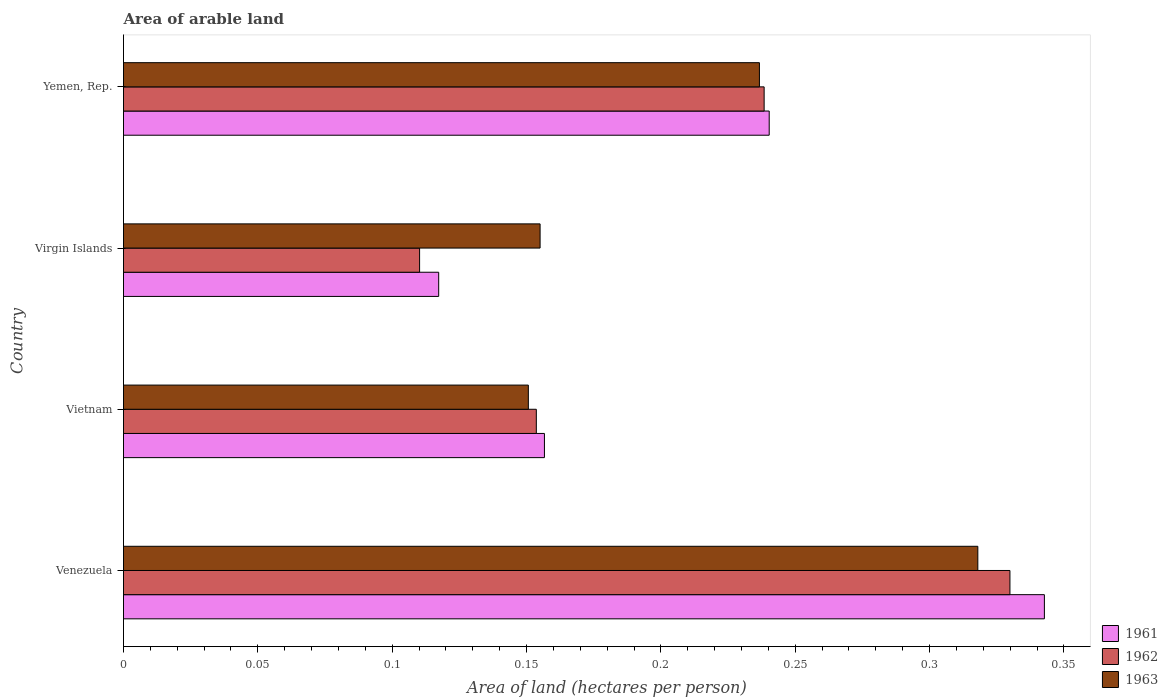How many groups of bars are there?
Offer a terse response. 4. Are the number of bars per tick equal to the number of legend labels?
Provide a short and direct response. Yes. How many bars are there on the 3rd tick from the bottom?
Your answer should be compact. 3. What is the label of the 1st group of bars from the top?
Provide a short and direct response. Yemen, Rep. In how many cases, is the number of bars for a given country not equal to the number of legend labels?
Keep it short and to the point. 0. What is the total arable land in 1963 in Venezuela?
Provide a succinct answer. 0.32. Across all countries, what is the maximum total arable land in 1961?
Your answer should be compact. 0.34. Across all countries, what is the minimum total arable land in 1961?
Provide a short and direct response. 0.12. In which country was the total arable land in 1962 maximum?
Provide a succinct answer. Venezuela. In which country was the total arable land in 1962 minimum?
Provide a short and direct response. Virgin Islands. What is the total total arable land in 1963 in the graph?
Keep it short and to the point. 0.86. What is the difference between the total arable land in 1962 in Vietnam and that in Yemen, Rep.?
Ensure brevity in your answer.  -0.08. What is the difference between the total arable land in 1963 in Virgin Islands and the total arable land in 1962 in Yemen, Rep.?
Make the answer very short. -0.08. What is the average total arable land in 1962 per country?
Ensure brevity in your answer.  0.21. What is the difference between the total arable land in 1963 and total arable land in 1962 in Virgin Islands?
Offer a very short reply. 0.04. What is the ratio of the total arable land in 1963 in Vietnam to that in Yemen, Rep.?
Your answer should be very brief. 0.64. Is the difference between the total arable land in 1963 in Venezuela and Vietnam greater than the difference between the total arable land in 1962 in Venezuela and Vietnam?
Offer a very short reply. No. What is the difference between the highest and the second highest total arable land in 1962?
Your response must be concise. 0.09. What is the difference between the highest and the lowest total arable land in 1962?
Your response must be concise. 0.22. In how many countries, is the total arable land in 1962 greater than the average total arable land in 1962 taken over all countries?
Your response must be concise. 2. Is it the case that in every country, the sum of the total arable land in 1961 and total arable land in 1963 is greater than the total arable land in 1962?
Provide a succinct answer. Yes. How many countries are there in the graph?
Your answer should be very brief. 4. Are the values on the major ticks of X-axis written in scientific E-notation?
Make the answer very short. No. Does the graph contain grids?
Your answer should be compact. No. How many legend labels are there?
Provide a succinct answer. 3. How are the legend labels stacked?
Provide a succinct answer. Vertical. What is the title of the graph?
Keep it short and to the point. Area of arable land. Does "1985" appear as one of the legend labels in the graph?
Provide a short and direct response. No. What is the label or title of the X-axis?
Provide a short and direct response. Area of land (hectares per person). What is the Area of land (hectares per person) of 1961 in Venezuela?
Provide a short and direct response. 0.34. What is the Area of land (hectares per person) in 1962 in Venezuela?
Ensure brevity in your answer.  0.33. What is the Area of land (hectares per person) in 1963 in Venezuela?
Keep it short and to the point. 0.32. What is the Area of land (hectares per person) in 1961 in Vietnam?
Offer a terse response. 0.16. What is the Area of land (hectares per person) of 1962 in Vietnam?
Provide a succinct answer. 0.15. What is the Area of land (hectares per person) in 1963 in Vietnam?
Provide a succinct answer. 0.15. What is the Area of land (hectares per person) in 1961 in Virgin Islands?
Offer a very short reply. 0.12. What is the Area of land (hectares per person) of 1962 in Virgin Islands?
Your answer should be very brief. 0.11. What is the Area of land (hectares per person) in 1963 in Virgin Islands?
Your answer should be very brief. 0.16. What is the Area of land (hectares per person) of 1961 in Yemen, Rep.?
Offer a very short reply. 0.24. What is the Area of land (hectares per person) in 1962 in Yemen, Rep.?
Ensure brevity in your answer.  0.24. What is the Area of land (hectares per person) of 1963 in Yemen, Rep.?
Keep it short and to the point. 0.24. Across all countries, what is the maximum Area of land (hectares per person) of 1961?
Your answer should be compact. 0.34. Across all countries, what is the maximum Area of land (hectares per person) in 1962?
Ensure brevity in your answer.  0.33. Across all countries, what is the maximum Area of land (hectares per person) in 1963?
Ensure brevity in your answer.  0.32. Across all countries, what is the minimum Area of land (hectares per person) of 1961?
Keep it short and to the point. 0.12. Across all countries, what is the minimum Area of land (hectares per person) in 1962?
Your response must be concise. 0.11. Across all countries, what is the minimum Area of land (hectares per person) of 1963?
Ensure brevity in your answer.  0.15. What is the total Area of land (hectares per person) in 1961 in the graph?
Ensure brevity in your answer.  0.86. What is the total Area of land (hectares per person) in 1962 in the graph?
Offer a very short reply. 0.83. What is the total Area of land (hectares per person) in 1963 in the graph?
Your answer should be compact. 0.86. What is the difference between the Area of land (hectares per person) of 1961 in Venezuela and that in Vietnam?
Provide a short and direct response. 0.19. What is the difference between the Area of land (hectares per person) of 1962 in Venezuela and that in Vietnam?
Provide a succinct answer. 0.18. What is the difference between the Area of land (hectares per person) in 1963 in Venezuela and that in Vietnam?
Offer a terse response. 0.17. What is the difference between the Area of land (hectares per person) in 1961 in Venezuela and that in Virgin Islands?
Provide a short and direct response. 0.23. What is the difference between the Area of land (hectares per person) of 1962 in Venezuela and that in Virgin Islands?
Your answer should be compact. 0.22. What is the difference between the Area of land (hectares per person) of 1963 in Venezuela and that in Virgin Islands?
Give a very brief answer. 0.16. What is the difference between the Area of land (hectares per person) in 1961 in Venezuela and that in Yemen, Rep.?
Offer a terse response. 0.1. What is the difference between the Area of land (hectares per person) of 1962 in Venezuela and that in Yemen, Rep.?
Ensure brevity in your answer.  0.09. What is the difference between the Area of land (hectares per person) in 1963 in Venezuela and that in Yemen, Rep.?
Your answer should be very brief. 0.08. What is the difference between the Area of land (hectares per person) of 1961 in Vietnam and that in Virgin Islands?
Keep it short and to the point. 0.04. What is the difference between the Area of land (hectares per person) of 1962 in Vietnam and that in Virgin Islands?
Keep it short and to the point. 0.04. What is the difference between the Area of land (hectares per person) of 1963 in Vietnam and that in Virgin Islands?
Provide a short and direct response. -0. What is the difference between the Area of land (hectares per person) in 1961 in Vietnam and that in Yemen, Rep.?
Give a very brief answer. -0.08. What is the difference between the Area of land (hectares per person) of 1962 in Vietnam and that in Yemen, Rep.?
Make the answer very short. -0.08. What is the difference between the Area of land (hectares per person) of 1963 in Vietnam and that in Yemen, Rep.?
Your answer should be very brief. -0.09. What is the difference between the Area of land (hectares per person) in 1961 in Virgin Islands and that in Yemen, Rep.?
Your answer should be compact. -0.12. What is the difference between the Area of land (hectares per person) in 1962 in Virgin Islands and that in Yemen, Rep.?
Provide a short and direct response. -0.13. What is the difference between the Area of land (hectares per person) in 1963 in Virgin Islands and that in Yemen, Rep.?
Make the answer very short. -0.08. What is the difference between the Area of land (hectares per person) in 1961 in Venezuela and the Area of land (hectares per person) in 1962 in Vietnam?
Ensure brevity in your answer.  0.19. What is the difference between the Area of land (hectares per person) in 1961 in Venezuela and the Area of land (hectares per person) in 1963 in Vietnam?
Your answer should be very brief. 0.19. What is the difference between the Area of land (hectares per person) in 1962 in Venezuela and the Area of land (hectares per person) in 1963 in Vietnam?
Keep it short and to the point. 0.18. What is the difference between the Area of land (hectares per person) of 1961 in Venezuela and the Area of land (hectares per person) of 1962 in Virgin Islands?
Your answer should be compact. 0.23. What is the difference between the Area of land (hectares per person) in 1961 in Venezuela and the Area of land (hectares per person) in 1963 in Virgin Islands?
Ensure brevity in your answer.  0.19. What is the difference between the Area of land (hectares per person) in 1962 in Venezuela and the Area of land (hectares per person) in 1963 in Virgin Islands?
Your answer should be compact. 0.17. What is the difference between the Area of land (hectares per person) of 1961 in Venezuela and the Area of land (hectares per person) of 1962 in Yemen, Rep.?
Your answer should be very brief. 0.1. What is the difference between the Area of land (hectares per person) in 1961 in Venezuela and the Area of land (hectares per person) in 1963 in Yemen, Rep.?
Make the answer very short. 0.11. What is the difference between the Area of land (hectares per person) of 1962 in Venezuela and the Area of land (hectares per person) of 1963 in Yemen, Rep.?
Your response must be concise. 0.09. What is the difference between the Area of land (hectares per person) in 1961 in Vietnam and the Area of land (hectares per person) in 1962 in Virgin Islands?
Give a very brief answer. 0.05. What is the difference between the Area of land (hectares per person) in 1961 in Vietnam and the Area of land (hectares per person) in 1963 in Virgin Islands?
Offer a terse response. 0. What is the difference between the Area of land (hectares per person) of 1962 in Vietnam and the Area of land (hectares per person) of 1963 in Virgin Islands?
Provide a succinct answer. -0. What is the difference between the Area of land (hectares per person) of 1961 in Vietnam and the Area of land (hectares per person) of 1962 in Yemen, Rep.?
Your answer should be very brief. -0.08. What is the difference between the Area of land (hectares per person) in 1961 in Vietnam and the Area of land (hectares per person) in 1963 in Yemen, Rep.?
Provide a short and direct response. -0.08. What is the difference between the Area of land (hectares per person) in 1962 in Vietnam and the Area of land (hectares per person) in 1963 in Yemen, Rep.?
Offer a terse response. -0.08. What is the difference between the Area of land (hectares per person) in 1961 in Virgin Islands and the Area of land (hectares per person) in 1962 in Yemen, Rep.?
Offer a terse response. -0.12. What is the difference between the Area of land (hectares per person) in 1961 in Virgin Islands and the Area of land (hectares per person) in 1963 in Yemen, Rep.?
Give a very brief answer. -0.12. What is the difference between the Area of land (hectares per person) in 1962 in Virgin Islands and the Area of land (hectares per person) in 1963 in Yemen, Rep.?
Your answer should be compact. -0.13. What is the average Area of land (hectares per person) of 1961 per country?
Give a very brief answer. 0.21. What is the average Area of land (hectares per person) of 1962 per country?
Keep it short and to the point. 0.21. What is the average Area of land (hectares per person) of 1963 per country?
Ensure brevity in your answer.  0.22. What is the difference between the Area of land (hectares per person) in 1961 and Area of land (hectares per person) in 1962 in Venezuela?
Your answer should be very brief. 0.01. What is the difference between the Area of land (hectares per person) in 1961 and Area of land (hectares per person) in 1963 in Venezuela?
Provide a short and direct response. 0.02. What is the difference between the Area of land (hectares per person) in 1962 and Area of land (hectares per person) in 1963 in Venezuela?
Offer a terse response. 0.01. What is the difference between the Area of land (hectares per person) of 1961 and Area of land (hectares per person) of 1962 in Vietnam?
Give a very brief answer. 0. What is the difference between the Area of land (hectares per person) in 1961 and Area of land (hectares per person) in 1963 in Vietnam?
Give a very brief answer. 0.01. What is the difference between the Area of land (hectares per person) in 1962 and Area of land (hectares per person) in 1963 in Vietnam?
Make the answer very short. 0. What is the difference between the Area of land (hectares per person) of 1961 and Area of land (hectares per person) of 1962 in Virgin Islands?
Offer a terse response. 0.01. What is the difference between the Area of land (hectares per person) in 1961 and Area of land (hectares per person) in 1963 in Virgin Islands?
Ensure brevity in your answer.  -0.04. What is the difference between the Area of land (hectares per person) in 1962 and Area of land (hectares per person) in 1963 in Virgin Islands?
Provide a short and direct response. -0.04. What is the difference between the Area of land (hectares per person) in 1961 and Area of land (hectares per person) in 1962 in Yemen, Rep.?
Provide a short and direct response. 0. What is the difference between the Area of land (hectares per person) in 1961 and Area of land (hectares per person) in 1963 in Yemen, Rep.?
Keep it short and to the point. 0. What is the difference between the Area of land (hectares per person) in 1962 and Area of land (hectares per person) in 1963 in Yemen, Rep.?
Provide a succinct answer. 0. What is the ratio of the Area of land (hectares per person) of 1961 in Venezuela to that in Vietnam?
Provide a succinct answer. 2.19. What is the ratio of the Area of land (hectares per person) of 1962 in Venezuela to that in Vietnam?
Your answer should be compact. 2.15. What is the ratio of the Area of land (hectares per person) in 1963 in Venezuela to that in Vietnam?
Ensure brevity in your answer.  2.11. What is the ratio of the Area of land (hectares per person) in 1961 in Venezuela to that in Virgin Islands?
Your answer should be very brief. 2.92. What is the ratio of the Area of land (hectares per person) in 1962 in Venezuela to that in Virgin Islands?
Your response must be concise. 2.99. What is the ratio of the Area of land (hectares per person) in 1963 in Venezuela to that in Virgin Islands?
Provide a short and direct response. 2.05. What is the ratio of the Area of land (hectares per person) of 1961 in Venezuela to that in Yemen, Rep.?
Your answer should be compact. 1.43. What is the ratio of the Area of land (hectares per person) in 1962 in Venezuela to that in Yemen, Rep.?
Provide a succinct answer. 1.38. What is the ratio of the Area of land (hectares per person) in 1963 in Venezuela to that in Yemen, Rep.?
Keep it short and to the point. 1.34. What is the ratio of the Area of land (hectares per person) in 1961 in Vietnam to that in Virgin Islands?
Your response must be concise. 1.34. What is the ratio of the Area of land (hectares per person) of 1962 in Vietnam to that in Virgin Islands?
Offer a terse response. 1.39. What is the ratio of the Area of land (hectares per person) of 1963 in Vietnam to that in Virgin Islands?
Keep it short and to the point. 0.97. What is the ratio of the Area of land (hectares per person) in 1961 in Vietnam to that in Yemen, Rep.?
Ensure brevity in your answer.  0.65. What is the ratio of the Area of land (hectares per person) in 1962 in Vietnam to that in Yemen, Rep.?
Your answer should be very brief. 0.64. What is the ratio of the Area of land (hectares per person) of 1963 in Vietnam to that in Yemen, Rep.?
Provide a succinct answer. 0.64. What is the ratio of the Area of land (hectares per person) in 1961 in Virgin Islands to that in Yemen, Rep.?
Make the answer very short. 0.49. What is the ratio of the Area of land (hectares per person) in 1962 in Virgin Islands to that in Yemen, Rep.?
Give a very brief answer. 0.46. What is the ratio of the Area of land (hectares per person) in 1963 in Virgin Islands to that in Yemen, Rep.?
Give a very brief answer. 0.66. What is the difference between the highest and the second highest Area of land (hectares per person) of 1961?
Make the answer very short. 0.1. What is the difference between the highest and the second highest Area of land (hectares per person) of 1962?
Provide a short and direct response. 0.09. What is the difference between the highest and the second highest Area of land (hectares per person) in 1963?
Provide a short and direct response. 0.08. What is the difference between the highest and the lowest Area of land (hectares per person) in 1961?
Make the answer very short. 0.23. What is the difference between the highest and the lowest Area of land (hectares per person) in 1962?
Offer a terse response. 0.22. What is the difference between the highest and the lowest Area of land (hectares per person) of 1963?
Provide a short and direct response. 0.17. 